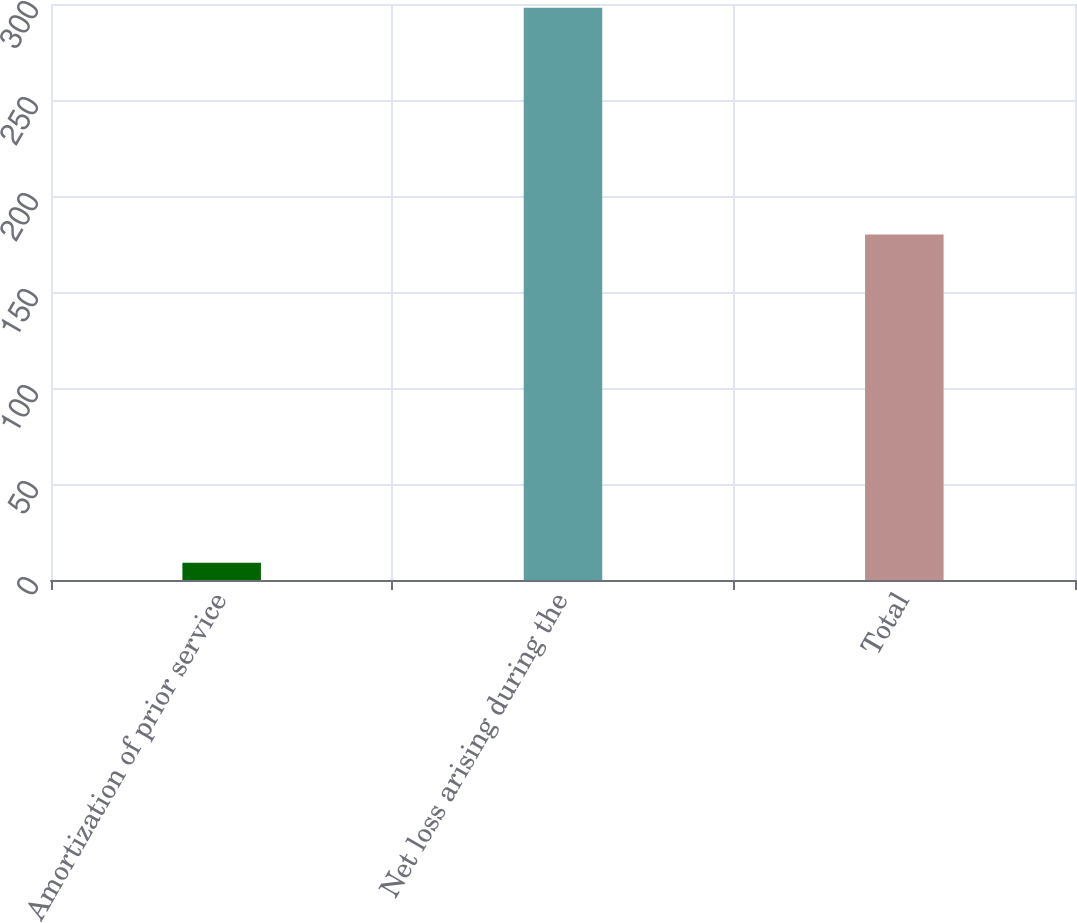Convert chart to OTSL. <chart><loc_0><loc_0><loc_500><loc_500><bar_chart><fcel>Amortization of prior service<fcel>Net loss arising during the<fcel>Total<nl><fcel>9<fcel>298<fcel>180<nl></chart> 